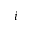<formula> <loc_0><loc_0><loc_500><loc_500>i</formula> 